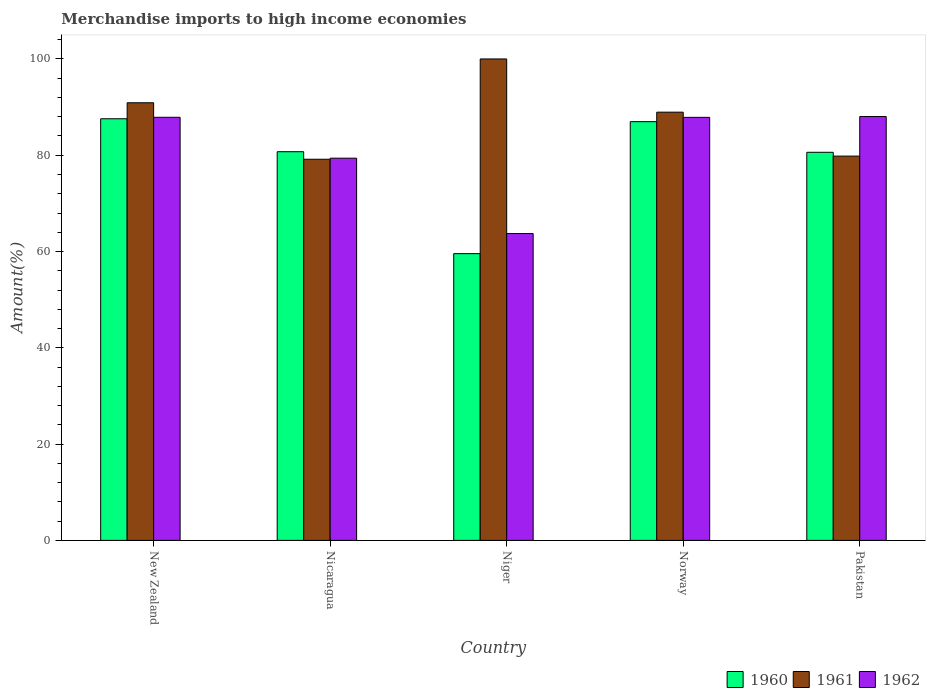Are the number of bars per tick equal to the number of legend labels?
Keep it short and to the point. Yes. Are the number of bars on each tick of the X-axis equal?
Offer a very short reply. Yes. How many bars are there on the 3rd tick from the left?
Make the answer very short. 3. How many bars are there on the 4th tick from the right?
Keep it short and to the point. 3. What is the label of the 5th group of bars from the left?
Provide a short and direct response. Pakistan. What is the percentage of amount earned from merchandise imports in 1961 in Norway?
Ensure brevity in your answer.  88.95. Across all countries, what is the maximum percentage of amount earned from merchandise imports in 1960?
Provide a short and direct response. 87.58. Across all countries, what is the minimum percentage of amount earned from merchandise imports in 1961?
Keep it short and to the point. 79.17. In which country was the percentage of amount earned from merchandise imports in 1962 maximum?
Keep it short and to the point. Pakistan. In which country was the percentage of amount earned from merchandise imports in 1962 minimum?
Your answer should be very brief. Niger. What is the total percentage of amount earned from merchandise imports in 1960 in the graph?
Your answer should be very brief. 395.45. What is the difference between the percentage of amount earned from merchandise imports in 1961 in Nicaragua and that in Norway?
Make the answer very short. -9.78. What is the difference between the percentage of amount earned from merchandise imports in 1962 in Pakistan and the percentage of amount earned from merchandise imports in 1961 in New Zealand?
Offer a terse response. -2.86. What is the average percentage of amount earned from merchandise imports in 1962 per country?
Ensure brevity in your answer.  81.38. What is the difference between the percentage of amount earned from merchandise imports of/in 1961 and percentage of amount earned from merchandise imports of/in 1960 in Pakistan?
Provide a short and direct response. -0.79. What is the ratio of the percentage of amount earned from merchandise imports in 1962 in Nicaragua to that in Norway?
Keep it short and to the point. 0.9. Is the difference between the percentage of amount earned from merchandise imports in 1961 in Nicaragua and Pakistan greater than the difference between the percentage of amount earned from merchandise imports in 1960 in Nicaragua and Pakistan?
Your answer should be very brief. No. What is the difference between the highest and the second highest percentage of amount earned from merchandise imports in 1962?
Provide a short and direct response. 0.17. What is the difference between the highest and the lowest percentage of amount earned from merchandise imports in 1960?
Offer a terse response. 28.02. In how many countries, is the percentage of amount earned from merchandise imports in 1960 greater than the average percentage of amount earned from merchandise imports in 1960 taken over all countries?
Provide a succinct answer. 4. Is the sum of the percentage of amount earned from merchandise imports in 1961 in New Zealand and Pakistan greater than the maximum percentage of amount earned from merchandise imports in 1962 across all countries?
Your response must be concise. Yes. What does the 3rd bar from the left in Norway represents?
Make the answer very short. 1962. Is it the case that in every country, the sum of the percentage of amount earned from merchandise imports in 1962 and percentage of amount earned from merchandise imports in 1960 is greater than the percentage of amount earned from merchandise imports in 1961?
Your response must be concise. Yes. How many bars are there?
Your answer should be very brief. 15. What is the difference between two consecutive major ticks on the Y-axis?
Offer a terse response. 20. Are the values on the major ticks of Y-axis written in scientific E-notation?
Provide a short and direct response. No. Does the graph contain grids?
Offer a terse response. No. Where does the legend appear in the graph?
Your answer should be very brief. Bottom right. How many legend labels are there?
Keep it short and to the point. 3. What is the title of the graph?
Offer a terse response. Merchandise imports to high income economies. Does "1999" appear as one of the legend labels in the graph?
Make the answer very short. No. What is the label or title of the Y-axis?
Your answer should be very brief. Amount(%). What is the Amount(%) of 1960 in New Zealand?
Offer a very short reply. 87.58. What is the Amount(%) in 1961 in New Zealand?
Offer a terse response. 90.9. What is the Amount(%) of 1962 in New Zealand?
Ensure brevity in your answer.  87.88. What is the Amount(%) in 1960 in Nicaragua?
Offer a very short reply. 80.73. What is the Amount(%) of 1961 in Nicaragua?
Offer a terse response. 79.17. What is the Amount(%) in 1962 in Nicaragua?
Provide a succinct answer. 79.39. What is the Amount(%) in 1960 in Niger?
Provide a succinct answer. 59.56. What is the Amount(%) of 1961 in Niger?
Provide a short and direct response. 100. What is the Amount(%) in 1962 in Niger?
Make the answer very short. 63.74. What is the Amount(%) in 1960 in Norway?
Provide a succinct answer. 86.97. What is the Amount(%) in 1961 in Norway?
Make the answer very short. 88.95. What is the Amount(%) in 1962 in Norway?
Provide a succinct answer. 87.87. What is the Amount(%) of 1960 in Pakistan?
Ensure brevity in your answer.  80.61. What is the Amount(%) of 1961 in Pakistan?
Offer a terse response. 79.82. What is the Amount(%) in 1962 in Pakistan?
Offer a very short reply. 88.04. Across all countries, what is the maximum Amount(%) of 1960?
Make the answer very short. 87.58. Across all countries, what is the maximum Amount(%) of 1962?
Make the answer very short. 88.04. Across all countries, what is the minimum Amount(%) of 1960?
Offer a terse response. 59.56. Across all countries, what is the minimum Amount(%) in 1961?
Your answer should be very brief. 79.17. Across all countries, what is the minimum Amount(%) of 1962?
Give a very brief answer. 63.74. What is the total Amount(%) of 1960 in the graph?
Your answer should be compact. 395.45. What is the total Amount(%) in 1961 in the graph?
Your answer should be very brief. 438.83. What is the total Amount(%) in 1962 in the graph?
Your response must be concise. 406.91. What is the difference between the Amount(%) in 1960 in New Zealand and that in Nicaragua?
Ensure brevity in your answer.  6.85. What is the difference between the Amount(%) in 1961 in New Zealand and that in Nicaragua?
Your answer should be very brief. 11.73. What is the difference between the Amount(%) in 1962 in New Zealand and that in Nicaragua?
Give a very brief answer. 8.49. What is the difference between the Amount(%) in 1960 in New Zealand and that in Niger?
Ensure brevity in your answer.  28.02. What is the difference between the Amount(%) in 1962 in New Zealand and that in Niger?
Make the answer very short. 24.15. What is the difference between the Amount(%) in 1960 in New Zealand and that in Norway?
Provide a short and direct response. 0.61. What is the difference between the Amount(%) of 1961 in New Zealand and that in Norway?
Your answer should be very brief. 1.95. What is the difference between the Amount(%) of 1962 in New Zealand and that in Norway?
Your response must be concise. 0.01. What is the difference between the Amount(%) in 1960 in New Zealand and that in Pakistan?
Provide a short and direct response. 6.97. What is the difference between the Amount(%) of 1961 in New Zealand and that in Pakistan?
Offer a terse response. 11.08. What is the difference between the Amount(%) in 1962 in New Zealand and that in Pakistan?
Provide a short and direct response. -0.15. What is the difference between the Amount(%) in 1960 in Nicaragua and that in Niger?
Keep it short and to the point. 21.17. What is the difference between the Amount(%) of 1961 in Nicaragua and that in Niger?
Your answer should be compact. -20.83. What is the difference between the Amount(%) of 1962 in Nicaragua and that in Niger?
Make the answer very short. 15.65. What is the difference between the Amount(%) of 1960 in Nicaragua and that in Norway?
Keep it short and to the point. -6.24. What is the difference between the Amount(%) of 1961 in Nicaragua and that in Norway?
Ensure brevity in your answer.  -9.78. What is the difference between the Amount(%) in 1962 in Nicaragua and that in Norway?
Offer a very short reply. -8.48. What is the difference between the Amount(%) of 1960 in Nicaragua and that in Pakistan?
Make the answer very short. 0.12. What is the difference between the Amount(%) of 1961 in Nicaragua and that in Pakistan?
Your response must be concise. -0.65. What is the difference between the Amount(%) in 1962 in Nicaragua and that in Pakistan?
Ensure brevity in your answer.  -8.65. What is the difference between the Amount(%) in 1960 in Niger and that in Norway?
Make the answer very short. -27.41. What is the difference between the Amount(%) in 1961 in Niger and that in Norway?
Give a very brief answer. 11.05. What is the difference between the Amount(%) in 1962 in Niger and that in Norway?
Provide a succinct answer. -24.13. What is the difference between the Amount(%) in 1960 in Niger and that in Pakistan?
Offer a terse response. -21.05. What is the difference between the Amount(%) in 1961 in Niger and that in Pakistan?
Ensure brevity in your answer.  20.18. What is the difference between the Amount(%) in 1962 in Niger and that in Pakistan?
Offer a very short reply. -24.3. What is the difference between the Amount(%) in 1960 in Norway and that in Pakistan?
Provide a short and direct response. 6.36. What is the difference between the Amount(%) in 1961 in Norway and that in Pakistan?
Offer a very short reply. 9.13. What is the difference between the Amount(%) in 1962 in Norway and that in Pakistan?
Your answer should be very brief. -0.17. What is the difference between the Amount(%) of 1960 in New Zealand and the Amount(%) of 1961 in Nicaragua?
Offer a terse response. 8.41. What is the difference between the Amount(%) of 1960 in New Zealand and the Amount(%) of 1962 in Nicaragua?
Your answer should be compact. 8.19. What is the difference between the Amount(%) in 1961 in New Zealand and the Amount(%) in 1962 in Nicaragua?
Provide a short and direct response. 11.51. What is the difference between the Amount(%) in 1960 in New Zealand and the Amount(%) in 1961 in Niger?
Provide a short and direct response. -12.42. What is the difference between the Amount(%) of 1960 in New Zealand and the Amount(%) of 1962 in Niger?
Your response must be concise. 23.84. What is the difference between the Amount(%) in 1961 in New Zealand and the Amount(%) in 1962 in Niger?
Offer a terse response. 27.16. What is the difference between the Amount(%) in 1960 in New Zealand and the Amount(%) in 1961 in Norway?
Offer a very short reply. -1.37. What is the difference between the Amount(%) of 1960 in New Zealand and the Amount(%) of 1962 in Norway?
Offer a very short reply. -0.29. What is the difference between the Amount(%) in 1961 in New Zealand and the Amount(%) in 1962 in Norway?
Keep it short and to the point. 3.03. What is the difference between the Amount(%) of 1960 in New Zealand and the Amount(%) of 1961 in Pakistan?
Ensure brevity in your answer.  7.76. What is the difference between the Amount(%) in 1960 in New Zealand and the Amount(%) in 1962 in Pakistan?
Your answer should be very brief. -0.46. What is the difference between the Amount(%) of 1961 in New Zealand and the Amount(%) of 1962 in Pakistan?
Offer a very short reply. 2.86. What is the difference between the Amount(%) in 1960 in Nicaragua and the Amount(%) in 1961 in Niger?
Ensure brevity in your answer.  -19.27. What is the difference between the Amount(%) of 1960 in Nicaragua and the Amount(%) of 1962 in Niger?
Provide a short and direct response. 17. What is the difference between the Amount(%) of 1961 in Nicaragua and the Amount(%) of 1962 in Niger?
Give a very brief answer. 15.43. What is the difference between the Amount(%) in 1960 in Nicaragua and the Amount(%) in 1961 in Norway?
Your answer should be compact. -8.21. What is the difference between the Amount(%) of 1960 in Nicaragua and the Amount(%) of 1962 in Norway?
Give a very brief answer. -7.14. What is the difference between the Amount(%) in 1961 in Nicaragua and the Amount(%) in 1962 in Norway?
Provide a succinct answer. -8.7. What is the difference between the Amount(%) of 1960 in Nicaragua and the Amount(%) of 1961 in Pakistan?
Your response must be concise. 0.91. What is the difference between the Amount(%) in 1960 in Nicaragua and the Amount(%) in 1962 in Pakistan?
Give a very brief answer. -7.31. What is the difference between the Amount(%) in 1961 in Nicaragua and the Amount(%) in 1962 in Pakistan?
Give a very brief answer. -8.87. What is the difference between the Amount(%) of 1960 in Niger and the Amount(%) of 1961 in Norway?
Give a very brief answer. -29.39. What is the difference between the Amount(%) of 1960 in Niger and the Amount(%) of 1962 in Norway?
Offer a terse response. -28.31. What is the difference between the Amount(%) of 1961 in Niger and the Amount(%) of 1962 in Norway?
Keep it short and to the point. 12.13. What is the difference between the Amount(%) of 1960 in Niger and the Amount(%) of 1961 in Pakistan?
Offer a very short reply. -20.26. What is the difference between the Amount(%) in 1960 in Niger and the Amount(%) in 1962 in Pakistan?
Offer a terse response. -28.48. What is the difference between the Amount(%) of 1961 in Niger and the Amount(%) of 1962 in Pakistan?
Provide a succinct answer. 11.96. What is the difference between the Amount(%) in 1960 in Norway and the Amount(%) in 1961 in Pakistan?
Make the answer very short. 7.15. What is the difference between the Amount(%) in 1960 in Norway and the Amount(%) in 1962 in Pakistan?
Offer a very short reply. -1.07. What is the difference between the Amount(%) in 1961 in Norway and the Amount(%) in 1962 in Pakistan?
Make the answer very short. 0.91. What is the average Amount(%) of 1960 per country?
Ensure brevity in your answer.  79.09. What is the average Amount(%) in 1961 per country?
Your answer should be very brief. 87.77. What is the average Amount(%) of 1962 per country?
Your response must be concise. 81.38. What is the difference between the Amount(%) in 1960 and Amount(%) in 1961 in New Zealand?
Your answer should be compact. -3.32. What is the difference between the Amount(%) in 1960 and Amount(%) in 1962 in New Zealand?
Ensure brevity in your answer.  -0.3. What is the difference between the Amount(%) in 1961 and Amount(%) in 1962 in New Zealand?
Offer a terse response. 3.02. What is the difference between the Amount(%) of 1960 and Amount(%) of 1961 in Nicaragua?
Your response must be concise. 1.56. What is the difference between the Amount(%) in 1960 and Amount(%) in 1962 in Nicaragua?
Ensure brevity in your answer.  1.34. What is the difference between the Amount(%) of 1961 and Amount(%) of 1962 in Nicaragua?
Your answer should be very brief. -0.22. What is the difference between the Amount(%) of 1960 and Amount(%) of 1961 in Niger?
Your response must be concise. -40.44. What is the difference between the Amount(%) of 1960 and Amount(%) of 1962 in Niger?
Offer a terse response. -4.18. What is the difference between the Amount(%) of 1961 and Amount(%) of 1962 in Niger?
Provide a succinct answer. 36.26. What is the difference between the Amount(%) in 1960 and Amount(%) in 1961 in Norway?
Offer a terse response. -1.97. What is the difference between the Amount(%) of 1960 and Amount(%) of 1962 in Norway?
Offer a terse response. -0.9. What is the difference between the Amount(%) of 1961 and Amount(%) of 1962 in Norway?
Your response must be concise. 1.08. What is the difference between the Amount(%) of 1960 and Amount(%) of 1961 in Pakistan?
Offer a very short reply. 0.79. What is the difference between the Amount(%) of 1960 and Amount(%) of 1962 in Pakistan?
Provide a short and direct response. -7.43. What is the difference between the Amount(%) of 1961 and Amount(%) of 1962 in Pakistan?
Offer a terse response. -8.22. What is the ratio of the Amount(%) in 1960 in New Zealand to that in Nicaragua?
Your response must be concise. 1.08. What is the ratio of the Amount(%) of 1961 in New Zealand to that in Nicaragua?
Ensure brevity in your answer.  1.15. What is the ratio of the Amount(%) of 1962 in New Zealand to that in Nicaragua?
Your answer should be very brief. 1.11. What is the ratio of the Amount(%) in 1960 in New Zealand to that in Niger?
Offer a very short reply. 1.47. What is the ratio of the Amount(%) in 1961 in New Zealand to that in Niger?
Keep it short and to the point. 0.91. What is the ratio of the Amount(%) of 1962 in New Zealand to that in Niger?
Ensure brevity in your answer.  1.38. What is the ratio of the Amount(%) of 1960 in New Zealand to that in Norway?
Provide a succinct answer. 1.01. What is the ratio of the Amount(%) in 1960 in New Zealand to that in Pakistan?
Offer a terse response. 1.09. What is the ratio of the Amount(%) in 1961 in New Zealand to that in Pakistan?
Offer a terse response. 1.14. What is the ratio of the Amount(%) of 1962 in New Zealand to that in Pakistan?
Make the answer very short. 1. What is the ratio of the Amount(%) in 1960 in Nicaragua to that in Niger?
Give a very brief answer. 1.36. What is the ratio of the Amount(%) of 1961 in Nicaragua to that in Niger?
Give a very brief answer. 0.79. What is the ratio of the Amount(%) in 1962 in Nicaragua to that in Niger?
Ensure brevity in your answer.  1.25. What is the ratio of the Amount(%) of 1960 in Nicaragua to that in Norway?
Make the answer very short. 0.93. What is the ratio of the Amount(%) of 1961 in Nicaragua to that in Norway?
Offer a very short reply. 0.89. What is the ratio of the Amount(%) in 1962 in Nicaragua to that in Norway?
Offer a terse response. 0.9. What is the ratio of the Amount(%) in 1960 in Nicaragua to that in Pakistan?
Keep it short and to the point. 1. What is the ratio of the Amount(%) of 1962 in Nicaragua to that in Pakistan?
Your answer should be very brief. 0.9. What is the ratio of the Amount(%) in 1960 in Niger to that in Norway?
Make the answer very short. 0.68. What is the ratio of the Amount(%) of 1961 in Niger to that in Norway?
Ensure brevity in your answer.  1.12. What is the ratio of the Amount(%) in 1962 in Niger to that in Norway?
Offer a terse response. 0.73. What is the ratio of the Amount(%) of 1960 in Niger to that in Pakistan?
Your answer should be compact. 0.74. What is the ratio of the Amount(%) in 1961 in Niger to that in Pakistan?
Your answer should be compact. 1.25. What is the ratio of the Amount(%) of 1962 in Niger to that in Pakistan?
Offer a very short reply. 0.72. What is the ratio of the Amount(%) of 1960 in Norway to that in Pakistan?
Keep it short and to the point. 1.08. What is the ratio of the Amount(%) of 1961 in Norway to that in Pakistan?
Offer a very short reply. 1.11. What is the difference between the highest and the second highest Amount(%) in 1960?
Provide a short and direct response. 0.61. What is the difference between the highest and the second highest Amount(%) of 1961?
Ensure brevity in your answer.  9.1. What is the difference between the highest and the second highest Amount(%) in 1962?
Your answer should be very brief. 0.15. What is the difference between the highest and the lowest Amount(%) of 1960?
Your response must be concise. 28.02. What is the difference between the highest and the lowest Amount(%) of 1961?
Provide a short and direct response. 20.83. What is the difference between the highest and the lowest Amount(%) of 1962?
Offer a very short reply. 24.3. 